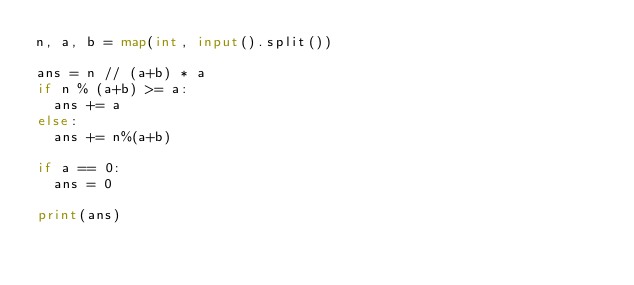Convert code to text. <code><loc_0><loc_0><loc_500><loc_500><_Python_>n, a, b = map(int, input().split())

ans = n // (a+b) * a
if n % (a+b) >= a:
  ans += a
else:
  ans += n%(a+b)

if a == 0:
  ans = 0

print(ans)</code> 